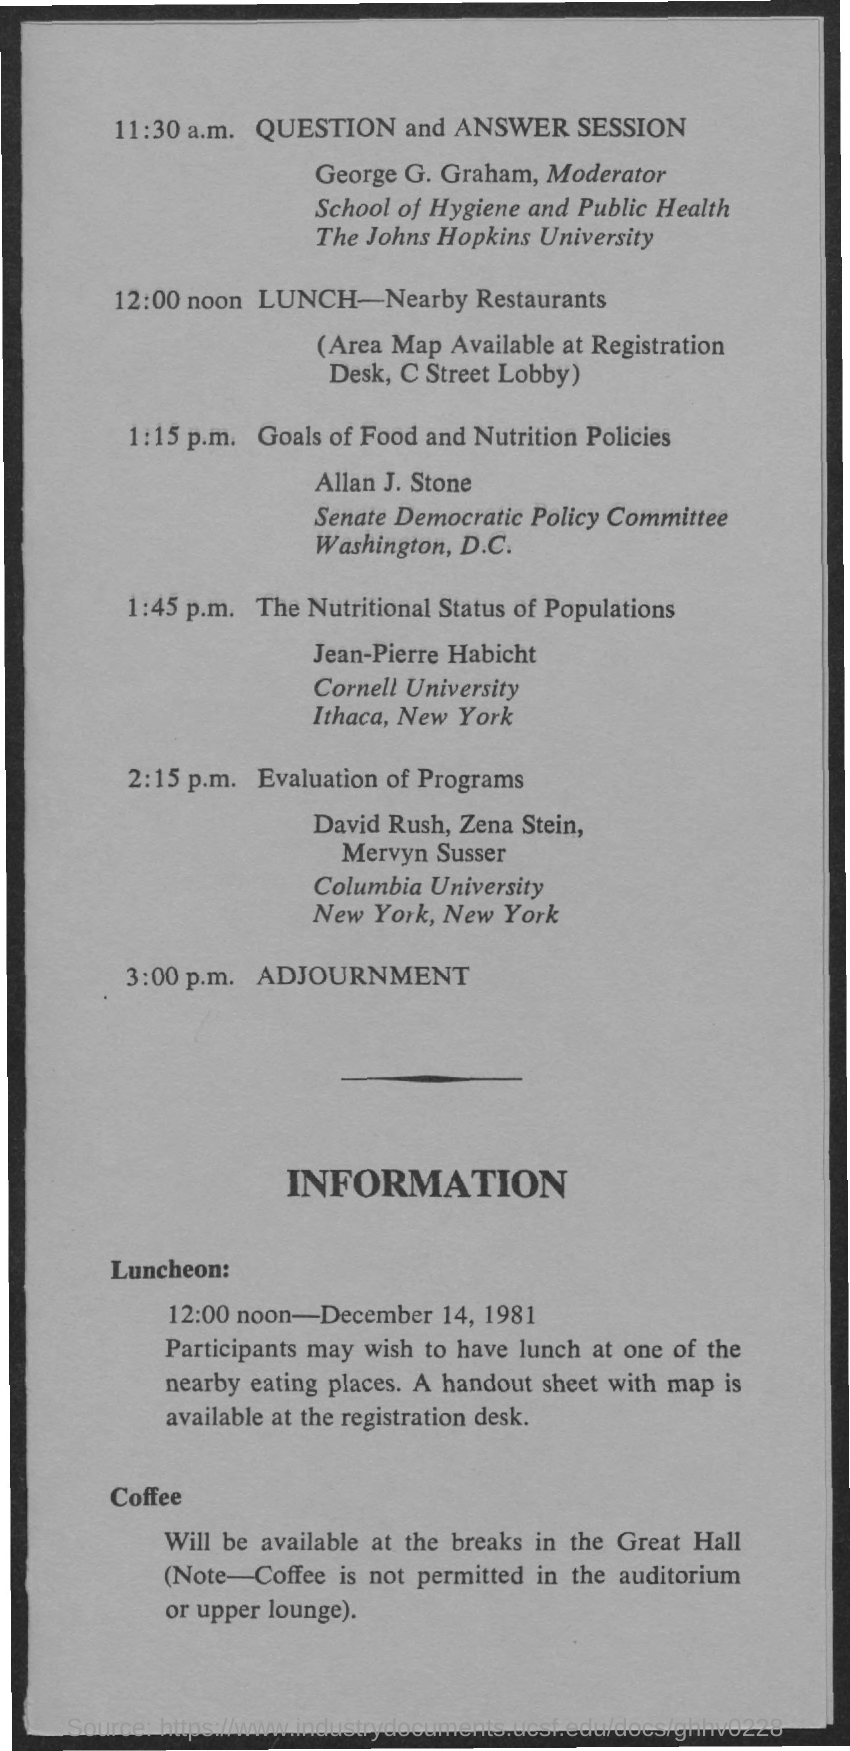Who all are presenting the session on 'Evaluation of Programs'?
Ensure brevity in your answer.  David Rush, Zena Stein, Mervyn Susser. Which session is carried out by Jean-Pierre Habicht?
Provide a short and direct response. The Nutritional Status of Populations. What time is the Question and answer session held?
Your answer should be compact. 11:30 a.m. Who is the moderator for question and answer session?
Keep it short and to the point. George G. Graham. What time is the lunch organized?
Offer a terse response. 12:00 noon. When are the sessions adjourned?
Your response must be concise. 3:00 p.m. Who is presenting the session on 'Goals of Food and Nutrition Policies'?
Your response must be concise. Allan J. Stone. 